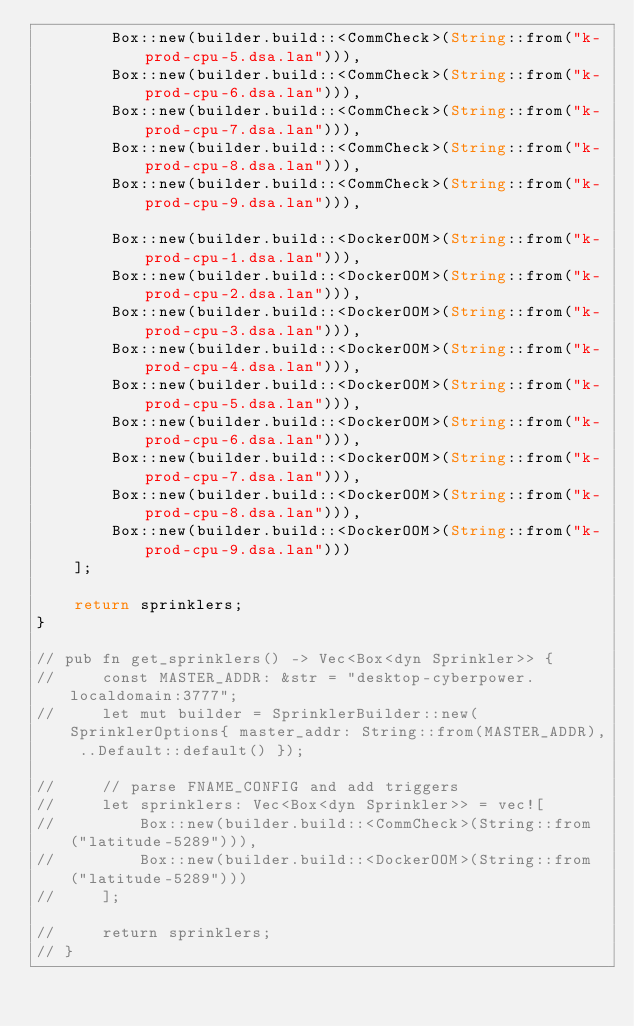<code> <loc_0><loc_0><loc_500><loc_500><_Rust_>        Box::new(builder.build::<CommCheck>(String::from("k-prod-cpu-5.dsa.lan"))),
        Box::new(builder.build::<CommCheck>(String::from("k-prod-cpu-6.dsa.lan"))),
        Box::new(builder.build::<CommCheck>(String::from("k-prod-cpu-7.dsa.lan"))),
        Box::new(builder.build::<CommCheck>(String::from("k-prod-cpu-8.dsa.lan"))),
        Box::new(builder.build::<CommCheck>(String::from("k-prod-cpu-9.dsa.lan"))),

        Box::new(builder.build::<DockerOOM>(String::from("k-prod-cpu-1.dsa.lan"))),
        Box::new(builder.build::<DockerOOM>(String::from("k-prod-cpu-2.dsa.lan"))),
        Box::new(builder.build::<DockerOOM>(String::from("k-prod-cpu-3.dsa.lan"))),
        Box::new(builder.build::<DockerOOM>(String::from("k-prod-cpu-4.dsa.lan"))),
        Box::new(builder.build::<DockerOOM>(String::from("k-prod-cpu-5.dsa.lan"))),
        Box::new(builder.build::<DockerOOM>(String::from("k-prod-cpu-6.dsa.lan"))),
        Box::new(builder.build::<DockerOOM>(String::from("k-prod-cpu-7.dsa.lan"))),
        Box::new(builder.build::<DockerOOM>(String::from("k-prod-cpu-8.dsa.lan"))),
        Box::new(builder.build::<DockerOOM>(String::from("k-prod-cpu-9.dsa.lan")))
    ];

    return sprinklers;
}

// pub fn get_sprinklers() -> Vec<Box<dyn Sprinkler>> {
//     const MASTER_ADDR: &str = "desktop-cyberpower.localdomain:3777";
//     let mut builder = SprinklerBuilder::new(SprinklerOptions{ master_addr: String::from(MASTER_ADDR), ..Default::default() });

//     // parse FNAME_CONFIG and add triggers
//     let sprinklers: Vec<Box<dyn Sprinkler>> = vec![
//         Box::new(builder.build::<CommCheck>(String::from("latitude-5289"))),
//         Box::new(builder.build::<DockerOOM>(String::from("latitude-5289")))
//     ];

//     return sprinklers;
// }
</code> 